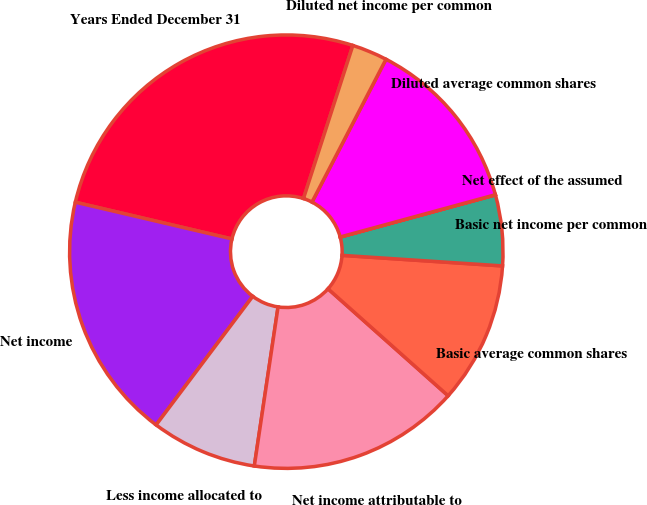<chart> <loc_0><loc_0><loc_500><loc_500><pie_chart><fcel>Years Ended December 31<fcel>Net income<fcel>Less income allocated to<fcel>Net income attributable to<fcel>Basic average common shares<fcel>Basic net income per common<fcel>Net effect of the assumed<fcel>Diluted average common shares<fcel>Diluted net income per common<nl><fcel>26.3%<fcel>18.41%<fcel>7.9%<fcel>15.78%<fcel>10.53%<fcel>5.27%<fcel>0.01%<fcel>13.16%<fcel>2.64%<nl></chart> 